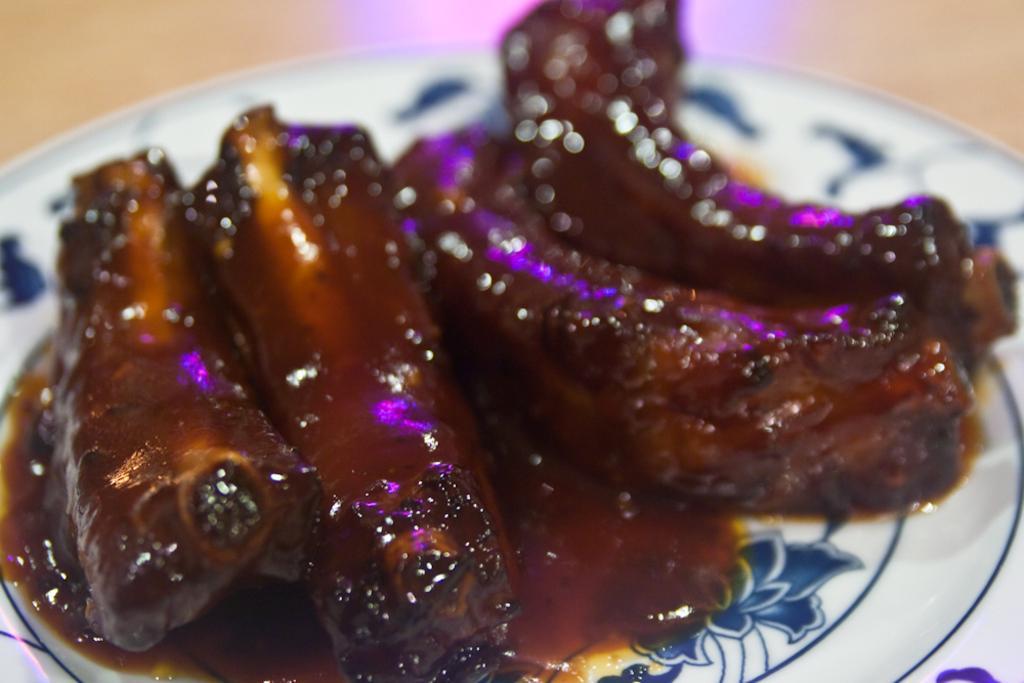Could you give a brief overview of what you see in this image? In this image, we can see a plate, there is some food on the plate. 